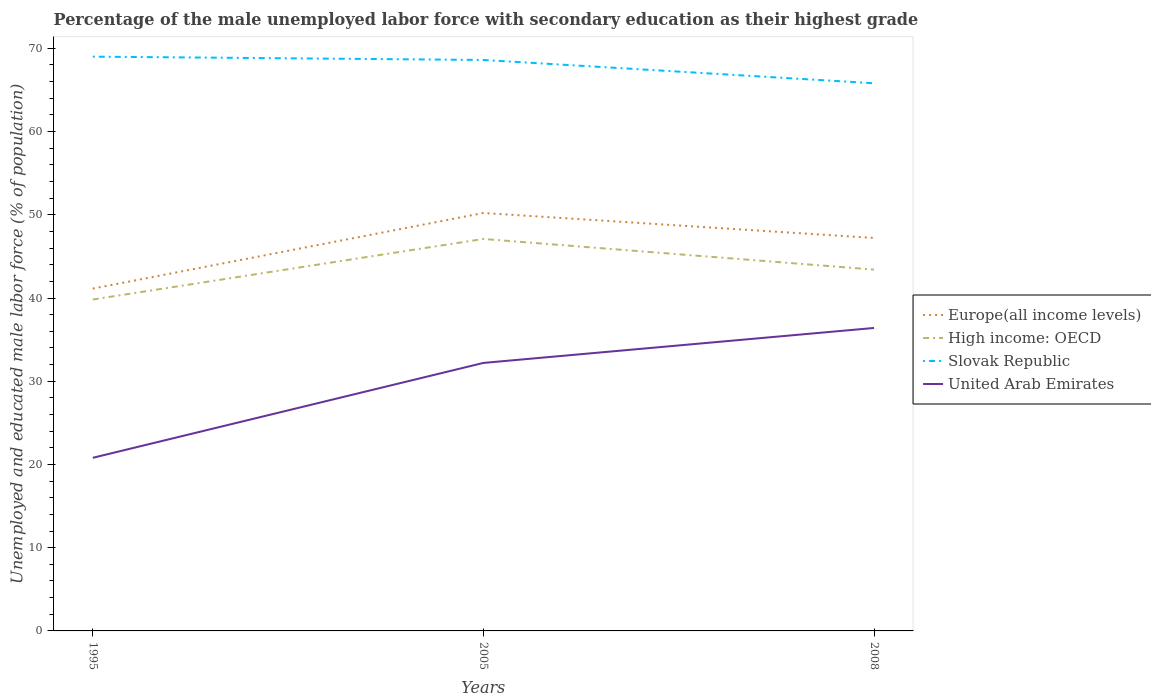Across all years, what is the maximum percentage of the unemployed male labor force with secondary education in Europe(all income levels)?
Ensure brevity in your answer.  41.13. In which year was the percentage of the unemployed male labor force with secondary education in United Arab Emirates maximum?
Offer a terse response. 1995. What is the total percentage of the unemployed male labor force with secondary education in High income: OECD in the graph?
Provide a short and direct response. -3.59. What is the difference between the highest and the second highest percentage of the unemployed male labor force with secondary education in Slovak Republic?
Make the answer very short. 3.2. Is the percentage of the unemployed male labor force with secondary education in United Arab Emirates strictly greater than the percentage of the unemployed male labor force with secondary education in Slovak Republic over the years?
Your answer should be very brief. Yes. How many lines are there?
Keep it short and to the point. 4. How many years are there in the graph?
Provide a succinct answer. 3. What is the difference between two consecutive major ticks on the Y-axis?
Ensure brevity in your answer.  10. Does the graph contain any zero values?
Your response must be concise. No. Does the graph contain grids?
Give a very brief answer. No. How many legend labels are there?
Your response must be concise. 4. What is the title of the graph?
Ensure brevity in your answer.  Percentage of the male unemployed labor force with secondary education as their highest grade. What is the label or title of the Y-axis?
Offer a very short reply. Unemployed and educated male labor force (% of population). What is the Unemployed and educated male labor force (% of population) of Europe(all income levels) in 1995?
Make the answer very short. 41.13. What is the Unemployed and educated male labor force (% of population) of High income: OECD in 1995?
Offer a very short reply. 39.82. What is the Unemployed and educated male labor force (% of population) of United Arab Emirates in 1995?
Offer a terse response. 20.8. What is the Unemployed and educated male labor force (% of population) of Europe(all income levels) in 2005?
Ensure brevity in your answer.  50.22. What is the Unemployed and educated male labor force (% of population) of High income: OECD in 2005?
Provide a succinct answer. 47.1. What is the Unemployed and educated male labor force (% of population) in Slovak Republic in 2005?
Give a very brief answer. 68.6. What is the Unemployed and educated male labor force (% of population) of United Arab Emirates in 2005?
Provide a short and direct response. 32.2. What is the Unemployed and educated male labor force (% of population) of Europe(all income levels) in 2008?
Your response must be concise. 47.21. What is the Unemployed and educated male labor force (% of population) of High income: OECD in 2008?
Provide a succinct answer. 43.41. What is the Unemployed and educated male labor force (% of population) of Slovak Republic in 2008?
Provide a short and direct response. 65.8. What is the Unemployed and educated male labor force (% of population) in United Arab Emirates in 2008?
Ensure brevity in your answer.  36.4. Across all years, what is the maximum Unemployed and educated male labor force (% of population) of Europe(all income levels)?
Give a very brief answer. 50.22. Across all years, what is the maximum Unemployed and educated male labor force (% of population) of High income: OECD?
Give a very brief answer. 47.1. Across all years, what is the maximum Unemployed and educated male labor force (% of population) of Slovak Republic?
Offer a very short reply. 69. Across all years, what is the maximum Unemployed and educated male labor force (% of population) of United Arab Emirates?
Give a very brief answer. 36.4. Across all years, what is the minimum Unemployed and educated male labor force (% of population) in Europe(all income levels)?
Give a very brief answer. 41.13. Across all years, what is the minimum Unemployed and educated male labor force (% of population) in High income: OECD?
Offer a very short reply. 39.82. Across all years, what is the minimum Unemployed and educated male labor force (% of population) in Slovak Republic?
Offer a terse response. 65.8. Across all years, what is the minimum Unemployed and educated male labor force (% of population) in United Arab Emirates?
Make the answer very short. 20.8. What is the total Unemployed and educated male labor force (% of population) of Europe(all income levels) in the graph?
Make the answer very short. 138.56. What is the total Unemployed and educated male labor force (% of population) of High income: OECD in the graph?
Your answer should be very brief. 130.33. What is the total Unemployed and educated male labor force (% of population) of Slovak Republic in the graph?
Offer a very short reply. 203.4. What is the total Unemployed and educated male labor force (% of population) in United Arab Emirates in the graph?
Your answer should be very brief. 89.4. What is the difference between the Unemployed and educated male labor force (% of population) of Europe(all income levels) in 1995 and that in 2005?
Your answer should be compact. -9.09. What is the difference between the Unemployed and educated male labor force (% of population) in High income: OECD in 1995 and that in 2005?
Your response must be concise. -7.27. What is the difference between the Unemployed and educated male labor force (% of population) of United Arab Emirates in 1995 and that in 2005?
Provide a short and direct response. -11.4. What is the difference between the Unemployed and educated male labor force (% of population) in Europe(all income levels) in 1995 and that in 2008?
Provide a succinct answer. -6.08. What is the difference between the Unemployed and educated male labor force (% of population) of High income: OECD in 1995 and that in 2008?
Offer a terse response. -3.59. What is the difference between the Unemployed and educated male labor force (% of population) of Slovak Republic in 1995 and that in 2008?
Ensure brevity in your answer.  3.2. What is the difference between the Unemployed and educated male labor force (% of population) in United Arab Emirates in 1995 and that in 2008?
Keep it short and to the point. -15.6. What is the difference between the Unemployed and educated male labor force (% of population) in Europe(all income levels) in 2005 and that in 2008?
Make the answer very short. 3. What is the difference between the Unemployed and educated male labor force (% of population) in High income: OECD in 2005 and that in 2008?
Make the answer very short. 3.68. What is the difference between the Unemployed and educated male labor force (% of population) in Slovak Republic in 2005 and that in 2008?
Provide a succinct answer. 2.8. What is the difference between the Unemployed and educated male labor force (% of population) of Europe(all income levels) in 1995 and the Unemployed and educated male labor force (% of population) of High income: OECD in 2005?
Offer a very short reply. -5.97. What is the difference between the Unemployed and educated male labor force (% of population) in Europe(all income levels) in 1995 and the Unemployed and educated male labor force (% of population) in Slovak Republic in 2005?
Keep it short and to the point. -27.47. What is the difference between the Unemployed and educated male labor force (% of population) of Europe(all income levels) in 1995 and the Unemployed and educated male labor force (% of population) of United Arab Emirates in 2005?
Provide a succinct answer. 8.93. What is the difference between the Unemployed and educated male labor force (% of population) in High income: OECD in 1995 and the Unemployed and educated male labor force (% of population) in Slovak Republic in 2005?
Provide a succinct answer. -28.78. What is the difference between the Unemployed and educated male labor force (% of population) in High income: OECD in 1995 and the Unemployed and educated male labor force (% of population) in United Arab Emirates in 2005?
Your answer should be compact. 7.62. What is the difference between the Unemployed and educated male labor force (% of population) of Slovak Republic in 1995 and the Unemployed and educated male labor force (% of population) of United Arab Emirates in 2005?
Keep it short and to the point. 36.8. What is the difference between the Unemployed and educated male labor force (% of population) in Europe(all income levels) in 1995 and the Unemployed and educated male labor force (% of population) in High income: OECD in 2008?
Offer a very short reply. -2.28. What is the difference between the Unemployed and educated male labor force (% of population) of Europe(all income levels) in 1995 and the Unemployed and educated male labor force (% of population) of Slovak Republic in 2008?
Your response must be concise. -24.67. What is the difference between the Unemployed and educated male labor force (% of population) in Europe(all income levels) in 1995 and the Unemployed and educated male labor force (% of population) in United Arab Emirates in 2008?
Give a very brief answer. 4.73. What is the difference between the Unemployed and educated male labor force (% of population) of High income: OECD in 1995 and the Unemployed and educated male labor force (% of population) of Slovak Republic in 2008?
Your answer should be compact. -25.98. What is the difference between the Unemployed and educated male labor force (% of population) in High income: OECD in 1995 and the Unemployed and educated male labor force (% of population) in United Arab Emirates in 2008?
Give a very brief answer. 3.42. What is the difference between the Unemployed and educated male labor force (% of population) in Slovak Republic in 1995 and the Unemployed and educated male labor force (% of population) in United Arab Emirates in 2008?
Your answer should be very brief. 32.6. What is the difference between the Unemployed and educated male labor force (% of population) of Europe(all income levels) in 2005 and the Unemployed and educated male labor force (% of population) of High income: OECD in 2008?
Provide a succinct answer. 6.8. What is the difference between the Unemployed and educated male labor force (% of population) in Europe(all income levels) in 2005 and the Unemployed and educated male labor force (% of population) in Slovak Republic in 2008?
Your answer should be very brief. -15.58. What is the difference between the Unemployed and educated male labor force (% of population) of Europe(all income levels) in 2005 and the Unemployed and educated male labor force (% of population) of United Arab Emirates in 2008?
Your answer should be compact. 13.82. What is the difference between the Unemployed and educated male labor force (% of population) of High income: OECD in 2005 and the Unemployed and educated male labor force (% of population) of Slovak Republic in 2008?
Your answer should be compact. -18.7. What is the difference between the Unemployed and educated male labor force (% of population) in High income: OECD in 2005 and the Unemployed and educated male labor force (% of population) in United Arab Emirates in 2008?
Offer a terse response. 10.7. What is the difference between the Unemployed and educated male labor force (% of population) of Slovak Republic in 2005 and the Unemployed and educated male labor force (% of population) of United Arab Emirates in 2008?
Give a very brief answer. 32.2. What is the average Unemployed and educated male labor force (% of population) of Europe(all income levels) per year?
Your answer should be very brief. 46.19. What is the average Unemployed and educated male labor force (% of population) in High income: OECD per year?
Make the answer very short. 43.44. What is the average Unemployed and educated male labor force (% of population) of Slovak Republic per year?
Your response must be concise. 67.8. What is the average Unemployed and educated male labor force (% of population) of United Arab Emirates per year?
Offer a terse response. 29.8. In the year 1995, what is the difference between the Unemployed and educated male labor force (% of population) in Europe(all income levels) and Unemployed and educated male labor force (% of population) in High income: OECD?
Your answer should be compact. 1.31. In the year 1995, what is the difference between the Unemployed and educated male labor force (% of population) in Europe(all income levels) and Unemployed and educated male labor force (% of population) in Slovak Republic?
Offer a terse response. -27.87. In the year 1995, what is the difference between the Unemployed and educated male labor force (% of population) in Europe(all income levels) and Unemployed and educated male labor force (% of population) in United Arab Emirates?
Provide a succinct answer. 20.33. In the year 1995, what is the difference between the Unemployed and educated male labor force (% of population) of High income: OECD and Unemployed and educated male labor force (% of population) of Slovak Republic?
Your answer should be very brief. -29.18. In the year 1995, what is the difference between the Unemployed and educated male labor force (% of population) in High income: OECD and Unemployed and educated male labor force (% of population) in United Arab Emirates?
Provide a short and direct response. 19.02. In the year 1995, what is the difference between the Unemployed and educated male labor force (% of population) of Slovak Republic and Unemployed and educated male labor force (% of population) of United Arab Emirates?
Your answer should be very brief. 48.2. In the year 2005, what is the difference between the Unemployed and educated male labor force (% of population) in Europe(all income levels) and Unemployed and educated male labor force (% of population) in High income: OECD?
Provide a succinct answer. 3.12. In the year 2005, what is the difference between the Unemployed and educated male labor force (% of population) in Europe(all income levels) and Unemployed and educated male labor force (% of population) in Slovak Republic?
Your answer should be compact. -18.38. In the year 2005, what is the difference between the Unemployed and educated male labor force (% of population) of Europe(all income levels) and Unemployed and educated male labor force (% of population) of United Arab Emirates?
Your answer should be compact. 18.02. In the year 2005, what is the difference between the Unemployed and educated male labor force (% of population) in High income: OECD and Unemployed and educated male labor force (% of population) in Slovak Republic?
Your answer should be compact. -21.5. In the year 2005, what is the difference between the Unemployed and educated male labor force (% of population) of High income: OECD and Unemployed and educated male labor force (% of population) of United Arab Emirates?
Keep it short and to the point. 14.89. In the year 2005, what is the difference between the Unemployed and educated male labor force (% of population) of Slovak Republic and Unemployed and educated male labor force (% of population) of United Arab Emirates?
Give a very brief answer. 36.4. In the year 2008, what is the difference between the Unemployed and educated male labor force (% of population) of Europe(all income levels) and Unemployed and educated male labor force (% of population) of High income: OECD?
Provide a succinct answer. 3.8. In the year 2008, what is the difference between the Unemployed and educated male labor force (% of population) of Europe(all income levels) and Unemployed and educated male labor force (% of population) of Slovak Republic?
Offer a very short reply. -18.59. In the year 2008, what is the difference between the Unemployed and educated male labor force (% of population) in Europe(all income levels) and Unemployed and educated male labor force (% of population) in United Arab Emirates?
Your answer should be very brief. 10.81. In the year 2008, what is the difference between the Unemployed and educated male labor force (% of population) in High income: OECD and Unemployed and educated male labor force (% of population) in Slovak Republic?
Keep it short and to the point. -22.39. In the year 2008, what is the difference between the Unemployed and educated male labor force (% of population) of High income: OECD and Unemployed and educated male labor force (% of population) of United Arab Emirates?
Offer a very short reply. 7.01. In the year 2008, what is the difference between the Unemployed and educated male labor force (% of population) in Slovak Republic and Unemployed and educated male labor force (% of population) in United Arab Emirates?
Ensure brevity in your answer.  29.4. What is the ratio of the Unemployed and educated male labor force (% of population) in Europe(all income levels) in 1995 to that in 2005?
Offer a terse response. 0.82. What is the ratio of the Unemployed and educated male labor force (% of population) of High income: OECD in 1995 to that in 2005?
Provide a succinct answer. 0.85. What is the ratio of the Unemployed and educated male labor force (% of population) of Slovak Republic in 1995 to that in 2005?
Offer a very short reply. 1.01. What is the ratio of the Unemployed and educated male labor force (% of population) in United Arab Emirates in 1995 to that in 2005?
Give a very brief answer. 0.65. What is the ratio of the Unemployed and educated male labor force (% of population) in Europe(all income levels) in 1995 to that in 2008?
Your answer should be compact. 0.87. What is the ratio of the Unemployed and educated male labor force (% of population) of High income: OECD in 1995 to that in 2008?
Keep it short and to the point. 0.92. What is the ratio of the Unemployed and educated male labor force (% of population) of Slovak Republic in 1995 to that in 2008?
Your response must be concise. 1.05. What is the ratio of the Unemployed and educated male labor force (% of population) in Europe(all income levels) in 2005 to that in 2008?
Offer a terse response. 1.06. What is the ratio of the Unemployed and educated male labor force (% of population) of High income: OECD in 2005 to that in 2008?
Keep it short and to the point. 1.08. What is the ratio of the Unemployed and educated male labor force (% of population) of Slovak Republic in 2005 to that in 2008?
Your answer should be very brief. 1.04. What is the ratio of the Unemployed and educated male labor force (% of population) of United Arab Emirates in 2005 to that in 2008?
Ensure brevity in your answer.  0.88. What is the difference between the highest and the second highest Unemployed and educated male labor force (% of population) of Europe(all income levels)?
Keep it short and to the point. 3. What is the difference between the highest and the second highest Unemployed and educated male labor force (% of population) of High income: OECD?
Provide a short and direct response. 3.68. What is the difference between the highest and the second highest Unemployed and educated male labor force (% of population) of United Arab Emirates?
Ensure brevity in your answer.  4.2. What is the difference between the highest and the lowest Unemployed and educated male labor force (% of population) in Europe(all income levels)?
Your answer should be compact. 9.09. What is the difference between the highest and the lowest Unemployed and educated male labor force (% of population) of High income: OECD?
Offer a very short reply. 7.27. What is the difference between the highest and the lowest Unemployed and educated male labor force (% of population) in Slovak Republic?
Make the answer very short. 3.2. 